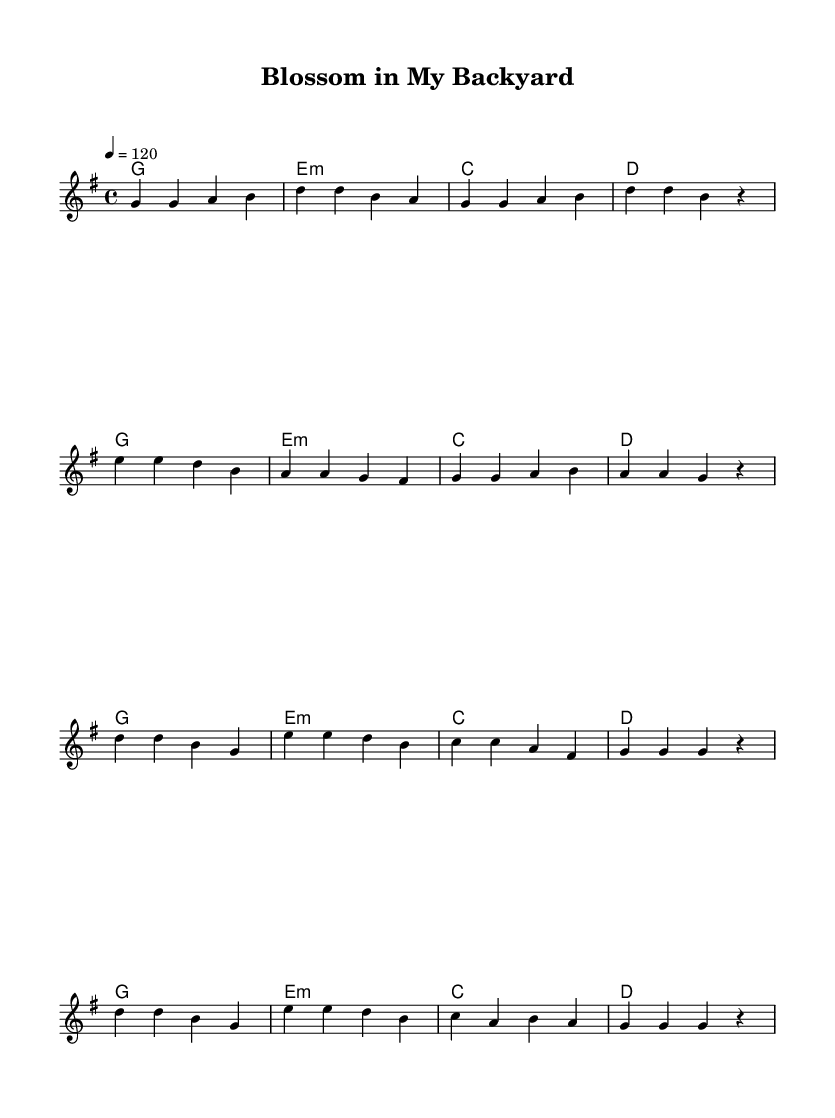What is the key signature of this music? The key signature shows one sharp, indicating that the piece is in G major.
Answer: G major What is the time signature of the piece? The time signature is present at the beginning of the sheet music and indicates that there are four beats per measure, which is represented as 4/4.
Answer: 4/4 What is the tempo marking for this piece? The tempo marking indicates the speed of the music and is specified as quarter note equals 120 beats per minute.
Answer: 120 How many measures are in the verse section? By counting the groupings and noting the structure of the verse in the sheet music, we see that there are eight measures in total.
Answer: Eight measures What chord follows the e minor chord during the verse? Examining the chord progression in the verse, we find that it is followed by a C major chord.
Answer: C major What is the primary theme expressed in the lyrics? The lyrics focus on the beauty and joy of gardening, referring to blooming flowers and a vibrant garden, which aligns with nature’s themes.
Answer: Gardening What type of song structure is primarily used in this piece? Looking at the sections of the music, we note a verse and chorus arrangement, which is common in pop music, allowing for repetition and memorable hooks.
Answer: Verse and chorus 